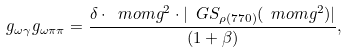<formula> <loc_0><loc_0><loc_500><loc_500>g _ { \omega \gamma } g _ { \omega \pi \pi } = \frac { \delta \cdot \ m o m g ^ { 2 } \cdot | \ G S _ { \rho ( 7 7 0 ) } ( \ m o m g ^ { 2 } ) | } { ( 1 + \beta ) } ,</formula> 